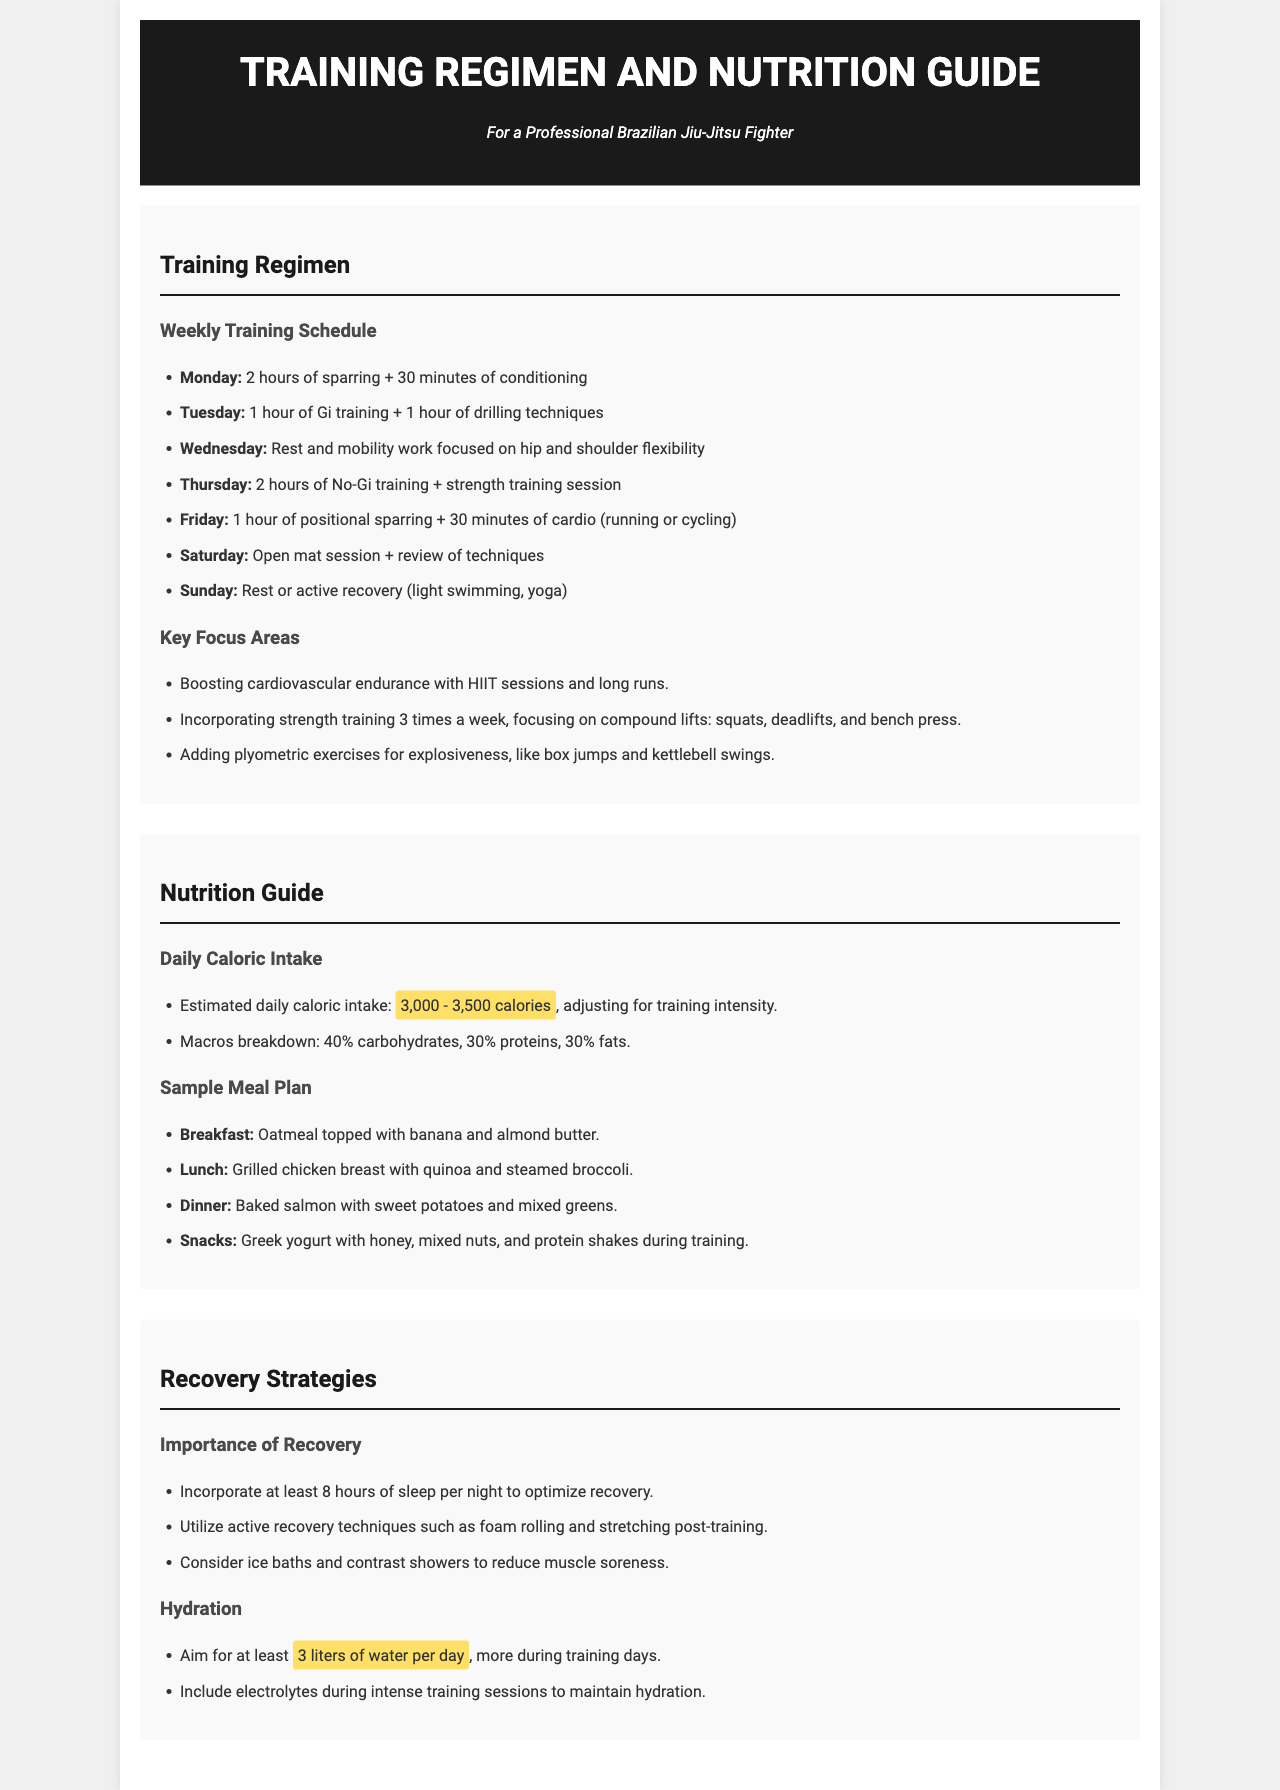What is the estimated daily caloric intake? The document states the estimated daily caloric intake is 3,000 - 3,500 calories, adjusting for training intensity.
Answer: 3,000 - 3,500 calories How many hours of sleep per night should be incorporated for recovery? The document emphasizes incorporating at least 8 hours of sleep per night to optimize recovery.
Answer: 8 hours What type of training is scheduled for Tuesday? The schedule for Tuesday includes 1 hour of Gi training and 1 hour of drilling techniques.
Answer: Gi training and drilling techniques What are the key focus areas in the training regimen? The key focus areas include boosting cardiovascular endurance, incorporating strength training, and adding plyometric exercises.
Answer: Cardiovascular endurance, strength training, plyometric exercises How much water should be consumed daily? The document recommends aiming for at least 3 liters of water per day, more during training days.
Answer: 3 liters 